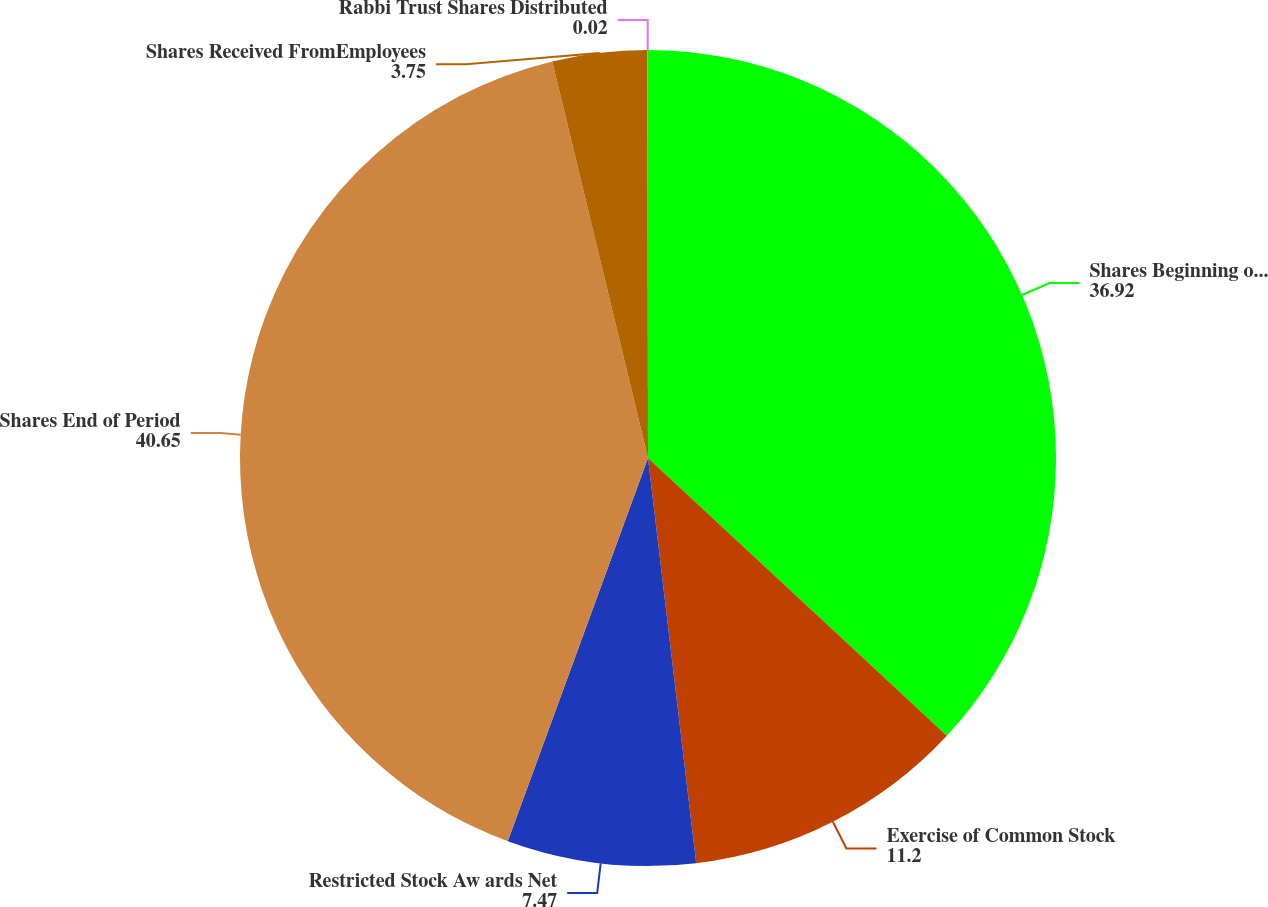Convert chart. <chart><loc_0><loc_0><loc_500><loc_500><pie_chart><fcel>Shares Beginning of Period<fcel>Exercise of Common Stock<fcel>Restricted Stock Aw ards Net<fcel>Shares End of Period<fcel>Shares Received FromEmployees<fcel>Rabbi Trust Shares Distributed<nl><fcel>36.92%<fcel>11.2%<fcel>7.47%<fcel>40.65%<fcel>3.75%<fcel>0.02%<nl></chart> 